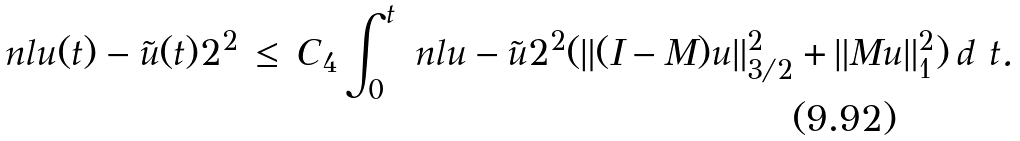Convert formula to latex. <formula><loc_0><loc_0><loc_500><loc_500>\ n l { u ( t ) - \tilde { u } ( t ) } { 2 } ^ { 2 } \, \leq \, C _ { 4 } \int _ { 0 } ^ { t } \ n l { u - \tilde { u } } { 2 } ^ { 2 } ( \| ( I - M ) u \| _ { 3 / 2 } ^ { 2 } + \| M u \| _ { 1 } ^ { 2 } ) \, d \ t .</formula> 